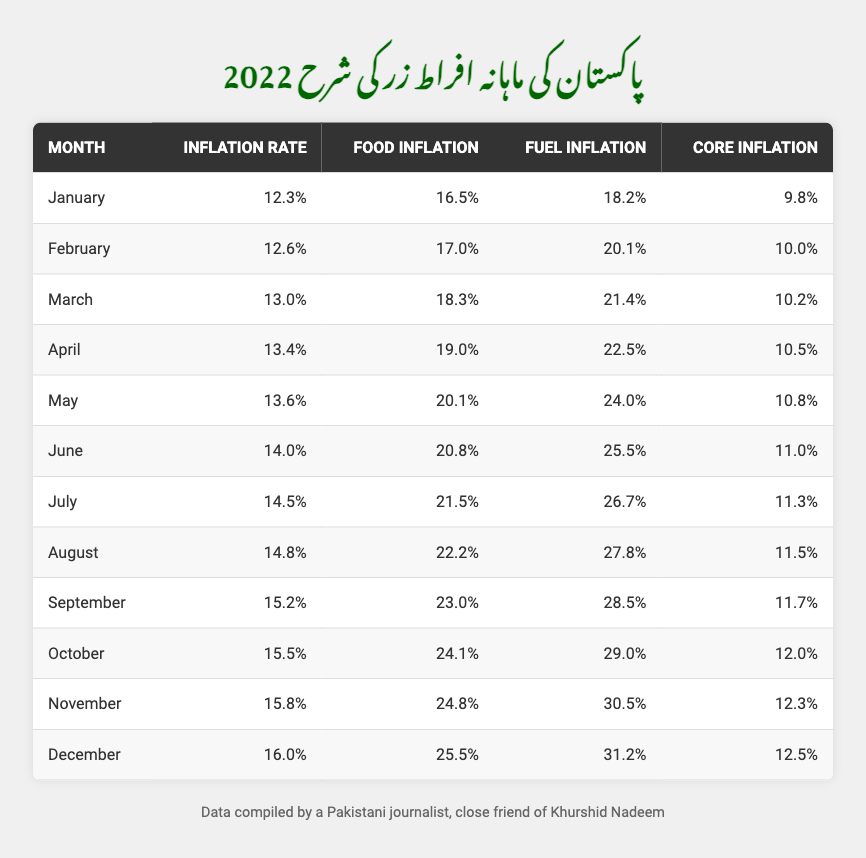What was the inflation rate in December 2022? The table shows that the inflation rate for December is listed as 16.0%.
Answer: 16.0% Which month had the highest food inflation rate? In the table, we compare the food inflation values: December (25.5%), November (24.8%), October (24.1%), etc. December has the highest food inflation rate.
Answer: December What is the difference between the inflation rates in January and February 2022? We subtract the January rate (12.3%) from the February rate (12.6%): 12.6% - 12.3% = 0.3%.
Answer: 0.3% Which month saw a fuel inflation rate of over 30%? The table shows fuel inflation rates for all months, and only December (31.2%) exceeds 30%.
Answer: December Calculate the average core inflation rate for the year 2022. To find the average, sum all core inflation rates: (9.8 + 10.0 + 10.2 + 10.5 + 10.8 + 11.0 + 11.3 + 11.5 + 11.7 + 12.0 + 12.3 + 12.5) = 134.6, then divide by 12: 134.6 / 12 = 11.22.
Answer: 11.22 Did the inflation rate increase every month in 2022? By examining the table, we see that each month’s inflation rate is higher than the previous month, confirming a consistent increase.
Answer: Yes What was the fuel inflation rate in June 2022? According to the table, the fuel inflation rate for June is recorded as 25.5%.
Answer: 25.5% In which month was the core inflation rate equal to 12.0%? The table reveals that the core inflation rate reaches 12.0% in October.
Answer: October What is the month-to-month increase in inflation rate from July to August? We find the difference between the inflation rates: August (14.8%) - July (14.5%) = 0.3%.
Answer: 0.3% What was the average food inflation rate from January to July 2022? We calculate the sum of food inflation from January to July: (16.5 + 17.0 + 18.3 + 19.0 + 20.1 + 20.8 + 21.5) = 133.2, then divide by the number of months (7): 133.2 / 7 = 19.03.
Answer: 19.03 Which month had a core inflation rate closest to 11.0%? Looking at the table, June has a core inflation of 11.0%, which is exactly what we’re looking for.
Answer: June 